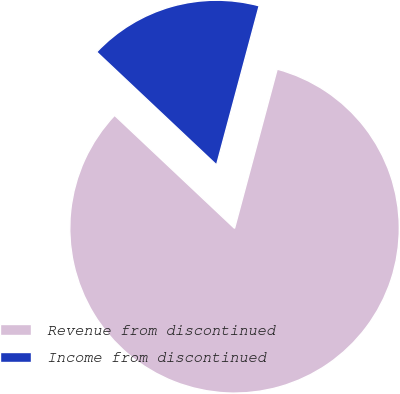Convert chart to OTSL. <chart><loc_0><loc_0><loc_500><loc_500><pie_chart><fcel>Revenue from discontinued<fcel>Income from discontinued<nl><fcel>82.86%<fcel>17.14%<nl></chart> 